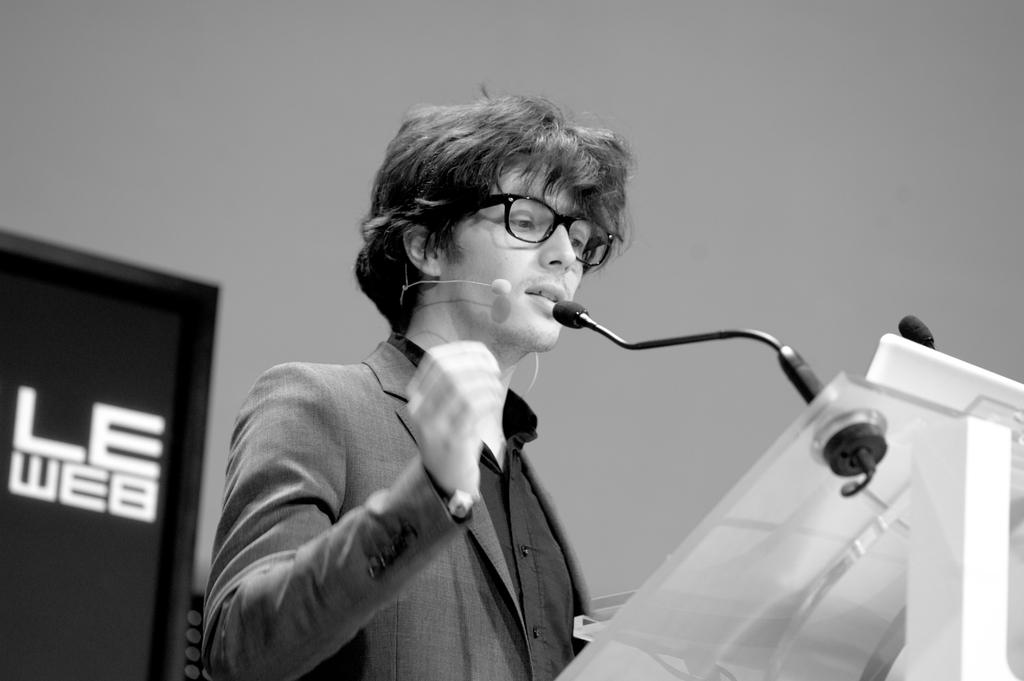What is the color scheme of the image? The image is a black and white photograph. Who is the main subject in the image? There is a man in the middle of the image. What objects are in front of the man? Microphones are present in front of the man. What structure is in front of the man, supporting the microphones? There is a podium in front of the man. How many beads are hanging from the podium in the image? There are no beads present in the image. What type of clam is visible on the podium in the image? There are no clams present in the image. 